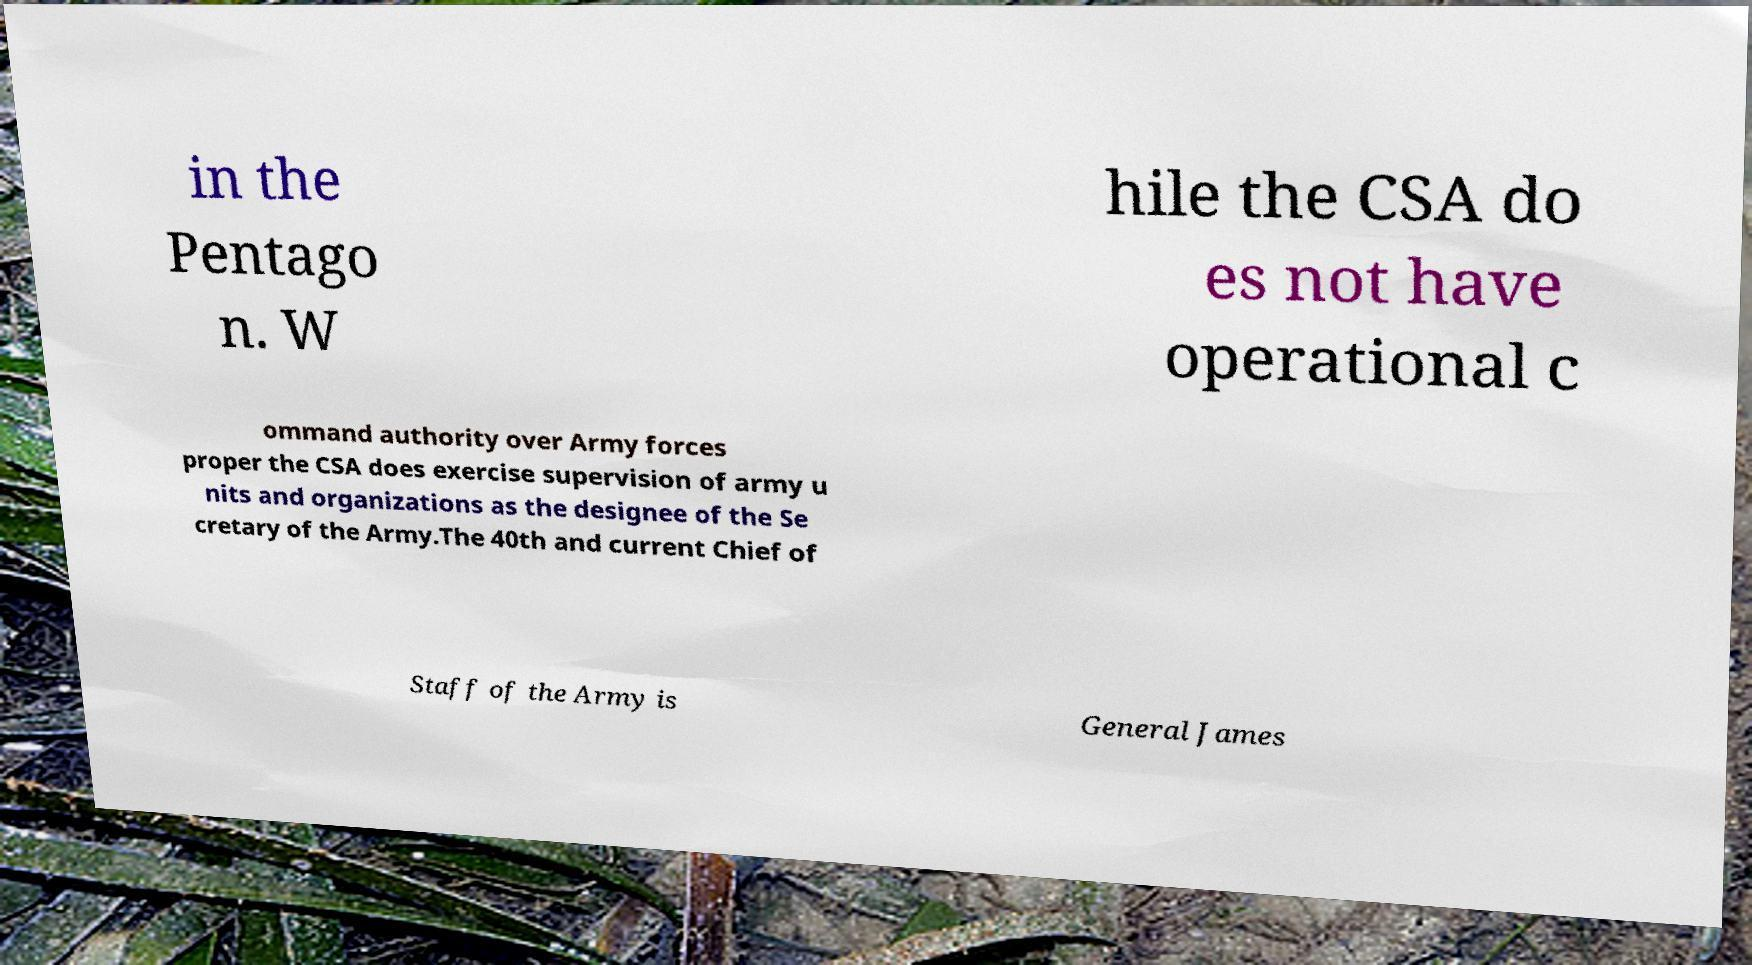Can you accurately transcribe the text from the provided image for me? in the Pentago n. W hile the CSA do es not have operational c ommand authority over Army forces proper the CSA does exercise supervision of army u nits and organizations as the designee of the Se cretary of the Army.The 40th and current Chief of Staff of the Army is General James 